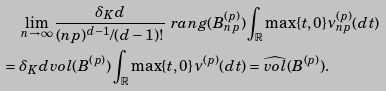<formula> <loc_0><loc_0><loc_500><loc_500>& \quad \, \lim _ { n \rightarrow \infty } \frac { \delta _ { K } d } { ( n p ) ^ { d - 1 } / ( d - 1 ) ! } \ r a n g ( B _ { n p } ^ { ( p ) } ) \int _ { \mathbb { R } } \max \{ t , 0 \} \nu _ { n p } ^ { ( p ) } ( d t ) \\ & = \delta _ { K } d v o l ( B ^ { ( p ) } ) \int _ { \mathbb { R } } \max \{ t , 0 \} \, \nu ^ { ( p ) } ( d t ) = \widehat { v o l } ( B ^ { ( p ) } ) .</formula> 